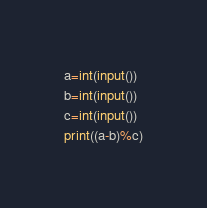<code> <loc_0><loc_0><loc_500><loc_500><_Python_>a=int(input())
b=int(input())
c=int(input())
print((a-b)%c)
</code> 